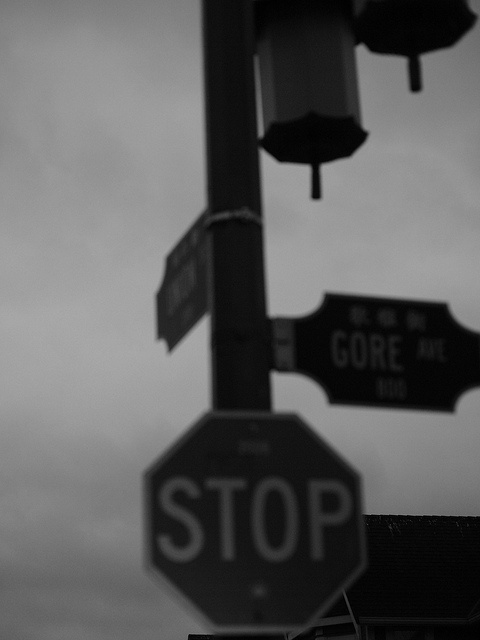Describe the objects in this image and their specific colors. I can see a stop sign in black and gray tones in this image. 